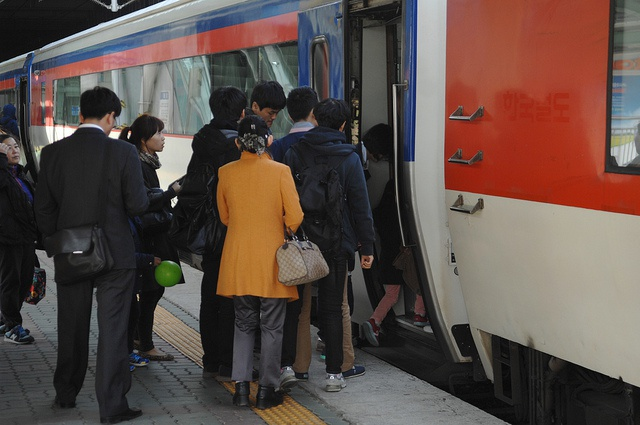Describe the objects in this image and their specific colors. I can see train in black, darkgray, and brown tones, people in black and gray tones, people in black, orange, and gray tones, people in black and gray tones, and people in black, gray, darkgray, and maroon tones in this image. 